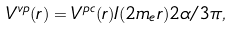Convert formula to latex. <formula><loc_0><loc_0><loc_500><loc_500>V ^ { v p } ( r ) = V ^ { p c } ( r ) I ( 2 m _ { e } r ) 2 \alpha / 3 \pi ,</formula> 